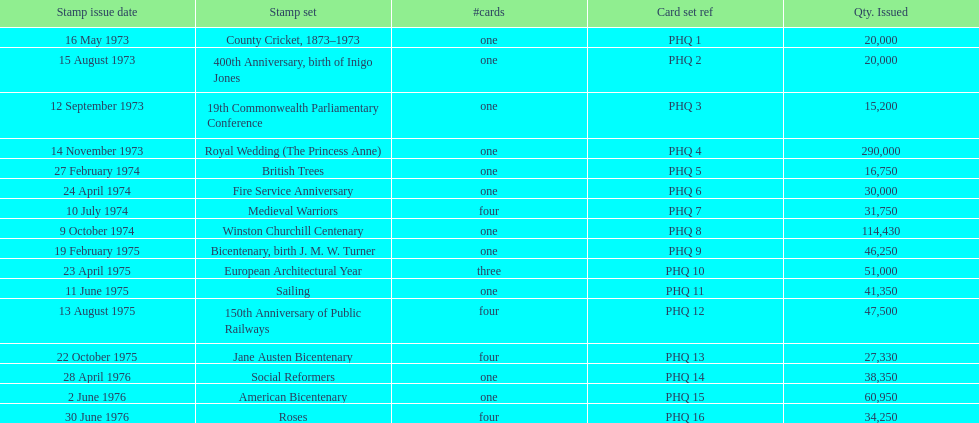Which stamp set witnessed the greatest volume distributed? Royal Wedding (The Princess Anne). 